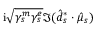<formula> <loc_0><loc_0><loc_500><loc_500>i \sqrt { \gamma _ { s } ^ { m } \gamma _ { s } ^ { e } } \Im ( \hat { d } _ { s } ^ { * } \cdot \hat { \mu } _ { s } )</formula> 